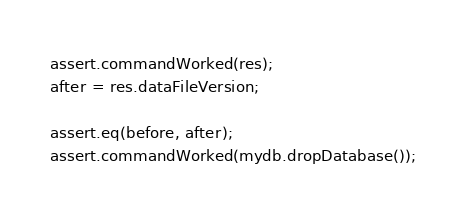Convert code to text. <code><loc_0><loc_0><loc_500><loc_500><_JavaScript_>assert.commandWorked(res);
after = res.dataFileVersion;

assert.eq(before, after);
assert.commandWorked(mydb.dropDatabase());
</code> 